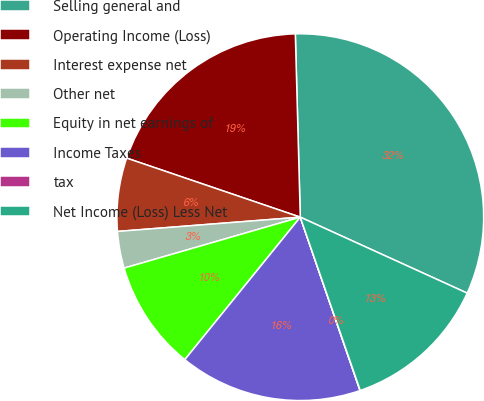Convert chart. <chart><loc_0><loc_0><loc_500><loc_500><pie_chart><fcel>Selling general and<fcel>Operating Income (Loss)<fcel>Interest expense net<fcel>Other net<fcel>Equity in net earnings of<fcel>Income Taxes<fcel>tax<fcel>Net Income (Loss) Less Net<nl><fcel>32.23%<fcel>19.35%<fcel>6.46%<fcel>3.24%<fcel>9.68%<fcel>16.12%<fcel>0.02%<fcel>12.9%<nl></chart> 